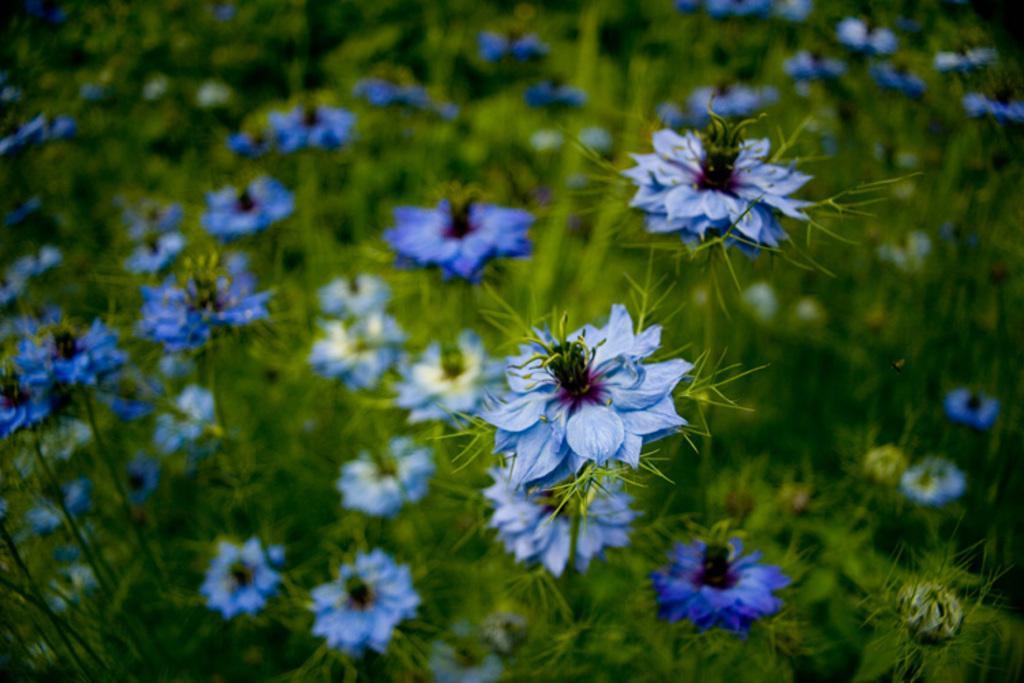Could you give a brief overview of what you see in this image? In this image we can see flower plants. 